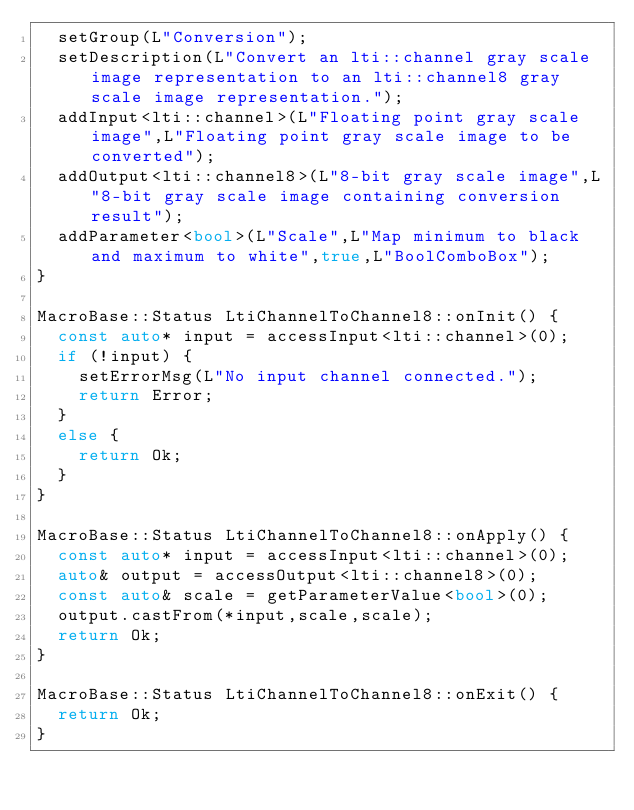<code> <loc_0><loc_0><loc_500><loc_500><_C++_>  setGroup(L"Conversion");
  setDescription(L"Convert an lti::channel gray scale image representation to an lti::channel8 gray scale image representation.");
  addInput<lti::channel>(L"Floating point gray scale image",L"Floating point gray scale image to be converted");
  addOutput<lti::channel8>(L"8-bit gray scale image",L"8-bit gray scale image containing conversion result");
  addParameter<bool>(L"Scale",L"Map minimum to black and maximum to white",true,L"BoolComboBox");
}

MacroBase::Status LtiChannelToChannel8::onInit() {
  const auto* input = accessInput<lti::channel>(0);
  if (!input) {
    setErrorMsg(L"No input channel connected.");
    return Error;
  }
  else {
    return Ok;
  }
}

MacroBase::Status LtiChannelToChannel8::onApply() {
  const auto* input = accessInput<lti::channel>(0);
  auto& output = accessOutput<lti::channel8>(0);
  const auto& scale = getParameterValue<bool>(0);
  output.castFrom(*input,scale,scale);
  return Ok;
}

MacroBase::Status LtiChannelToChannel8::onExit() {
  return Ok;
}
</code> 